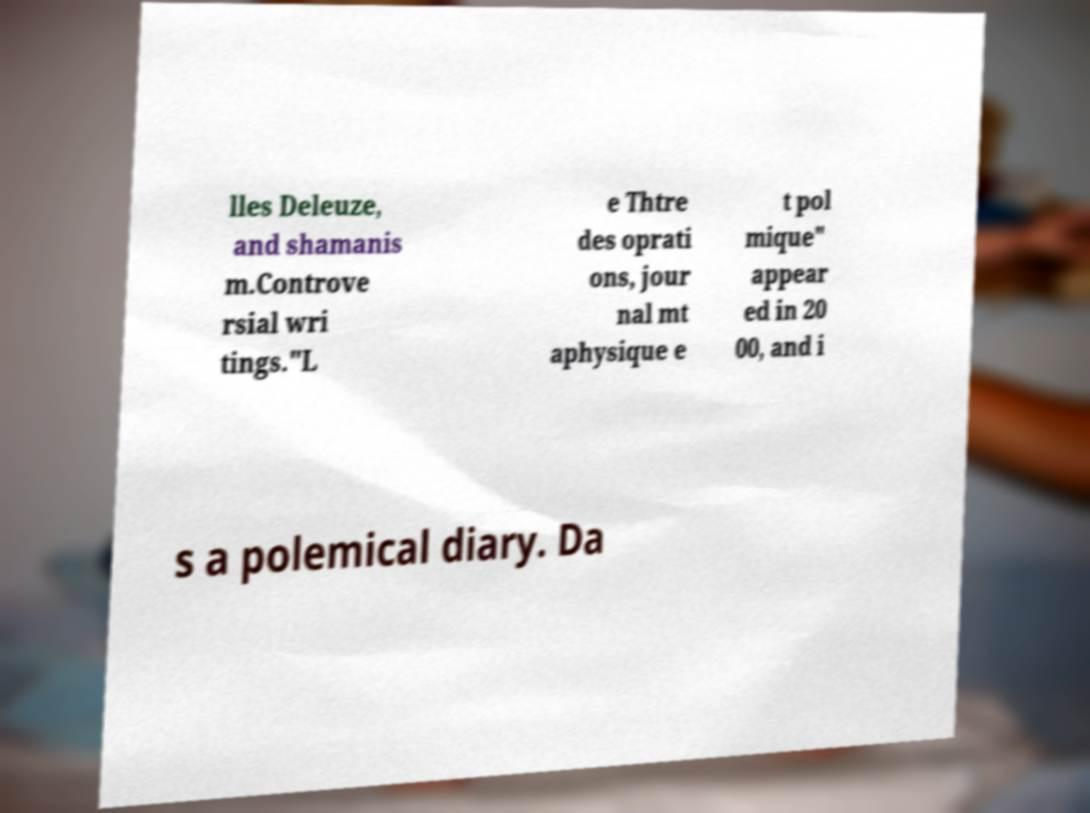Please read and relay the text visible in this image. What does it say? lles Deleuze, and shamanis m.Controve rsial wri tings."L e Thtre des oprati ons, jour nal mt aphysique e t pol mique" appear ed in 20 00, and i s a polemical diary. Da 